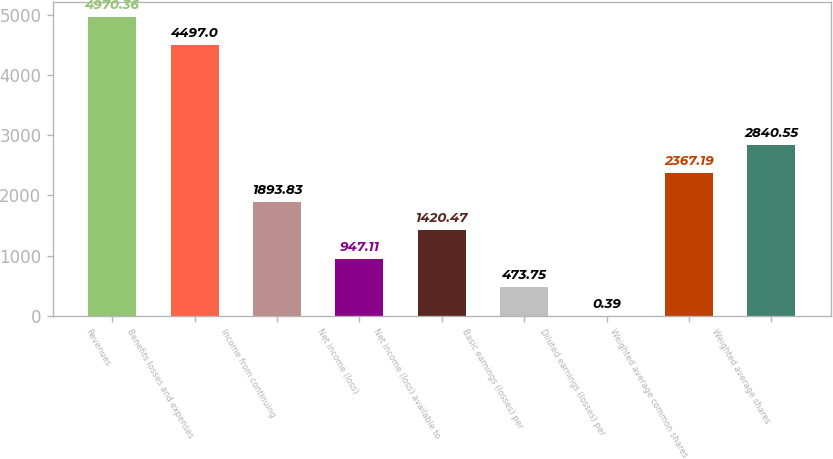Convert chart to OTSL. <chart><loc_0><loc_0><loc_500><loc_500><bar_chart><fcel>Revenues<fcel>Benefits losses and expenses<fcel>Income from continuing<fcel>Net income (loss)<fcel>Net income (loss) available to<fcel>Basic earnings (losses) per<fcel>Diluted earnings (losses) per<fcel>Weighted average common shares<fcel>Weighted average shares<nl><fcel>4970.36<fcel>4497<fcel>1893.83<fcel>947.11<fcel>1420.47<fcel>473.75<fcel>0.39<fcel>2367.19<fcel>2840.55<nl></chart> 